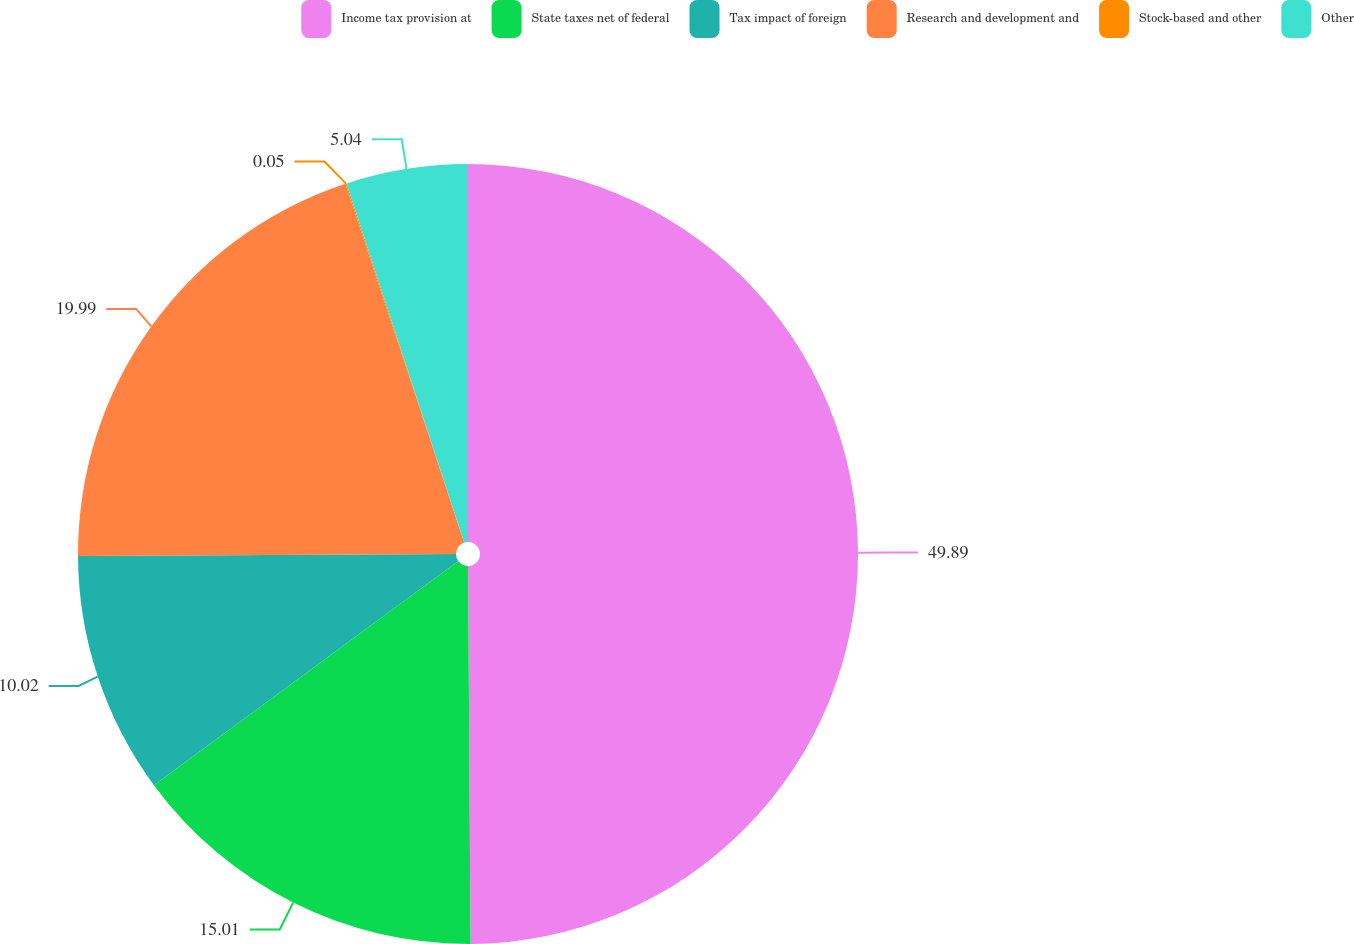Convert chart. <chart><loc_0><loc_0><loc_500><loc_500><pie_chart><fcel>Income tax provision at<fcel>State taxes net of federal<fcel>Tax impact of foreign<fcel>Research and development and<fcel>Stock-based and other<fcel>Other<nl><fcel>49.9%<fcel>15.01%<fcel>10.02%<fcel>19.99%<fcel>0.05%<fcel>5.04%<nl></chart> 